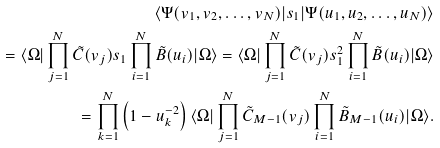<formula> <loc_0><loc_0><loc_500><loc_500>\langle \Psi ( v _ { 1 } , v _ { 2 } , \dots , v _ { N } ) | s _ { 1 } | \Psi ( u _ { 1 } , u _ { 2 } , \dots , u _ { N } ) \rangle \\ = \langle \Omega | \prod _ { j = 1 } ^ { N } \tilde { C } ( v _ { j } ) s _ { 1 } \prod _ { i = 1 } ^ { N } \tilde { B } ( u _ { i } ) | \Omega \rangle = \langle \Omega | \prod _ { j = 1 } ^ { N } \tilde { C } ( v _ { j } ) s _ { 1 } ^ { 2 } \prod _ { i = 1 } ^ { N } \tilde { B } ( u _ { i } ) | \Omega \rangle \\ = \prod _ { k = 1 } ^ { N } \left ( 1 - u _ { k } ^ { - 2 } \right ) \langle \Omega | \prod _ { j = 1 } ^ { N } \tilde { C } _ { M - 1 } ( v _ { j } ) \prod _ { i = 1 } ^ { N } \tilde { B } _ { M - 1 } ( u _ { i } ) | \Omega \rangle .</formula> 